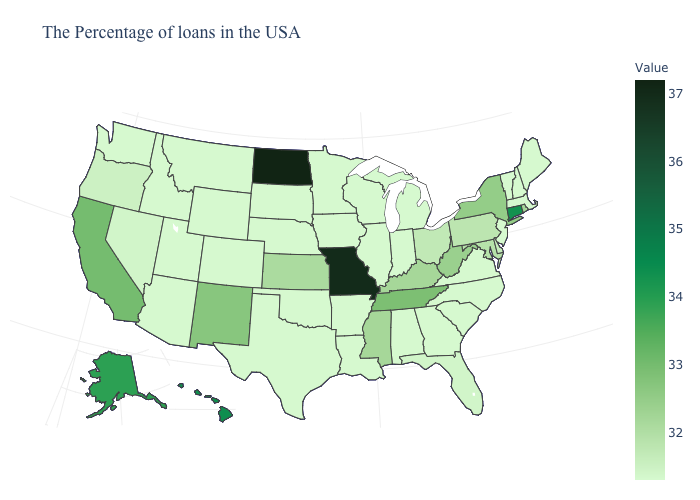Does New Jersey have the highest value in the USA?
Quick response, please. No. Does the map have missing data?
Give a very brief answer. No. Which states hav the highest value in the Northeast?
Quick response, please. Connecticut. Among the states that border Mississippi , does Alabama have the highest value?
Concise answer only. No. 